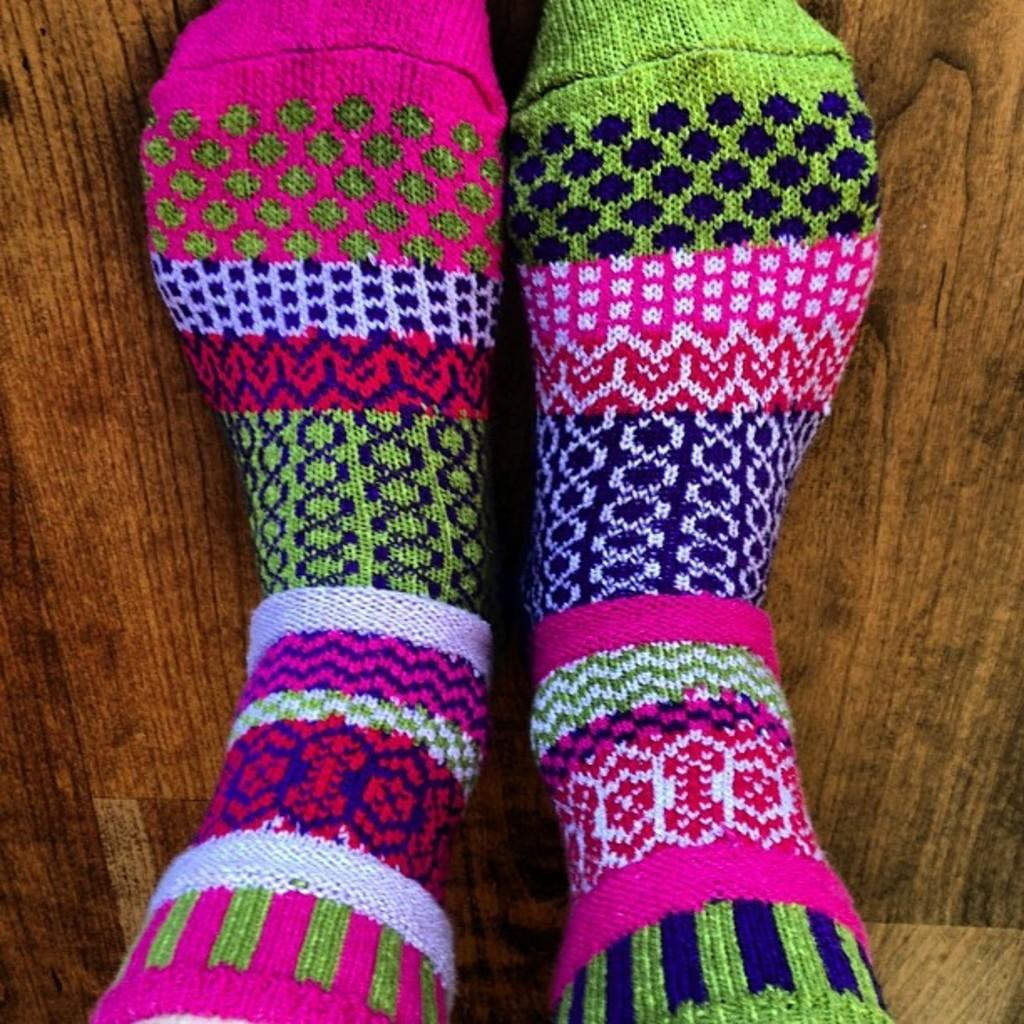What type of clothing items are in the image? There are socks in the image. What can be said about the colors of the socks? The socks are in multiple colors. What type of surface can be seen in the image? There is a wooden surface in the image. How many snakes are slithering on the wooden surface in the image? There are no snakes present in the image; it only features socks and a wooden surface. 